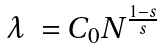<formula> <loc_0><loc_0><loc_500><loc_500>\begin{array} { l l } \lambda & = C _ { 0 } N ^ { \frac { 1 - s } { s } } \end{array}</formula> 